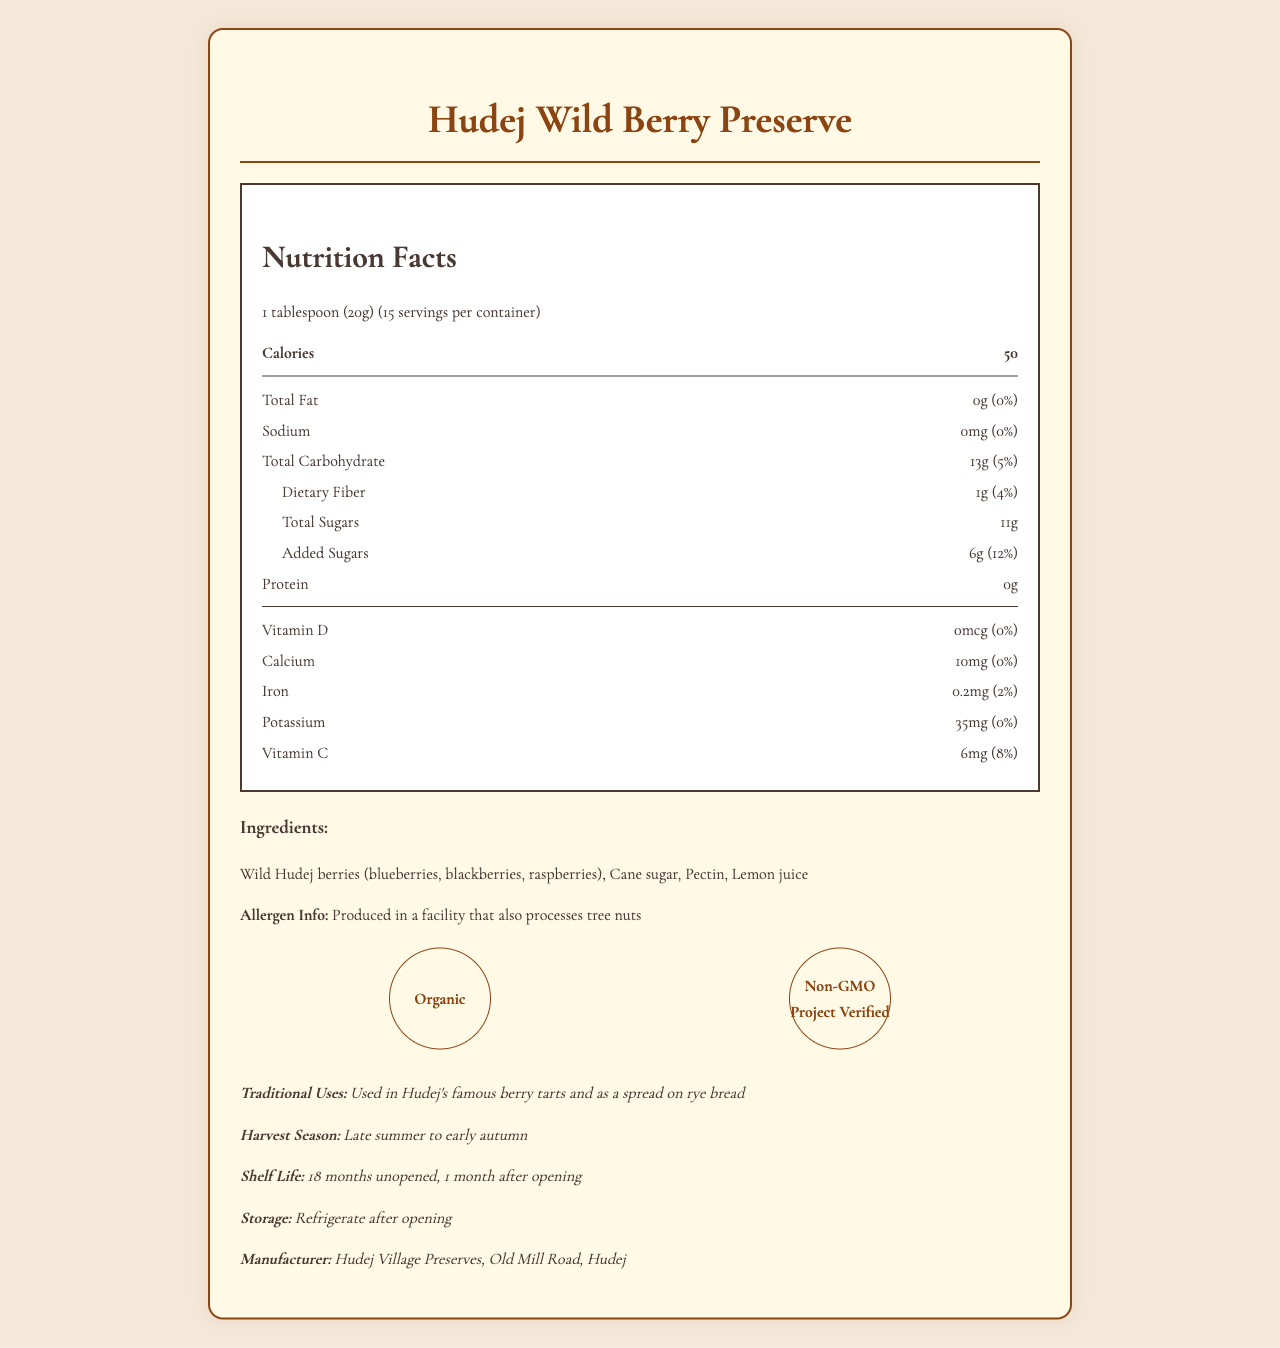what is the serving size? The document states that the serving size is 1 tablespoon, which is equivalent to 20 grams.
Answer: 1 tablespoon (20g) how many calories are in one serving? The "Calories" section of the Nutrition Facts Label shows that there are 50 calories per serving.
Answer: 50 calories what is the total fat content in one serving? The document lists total fat as 0 grams in one serving.
Answer: 0g how much dietary fiber is in a serving, and what percentage of the daily value does it represent? The Nutrition Facts Label states that there is 1 gram of dietary fiber per serving, which is 4% of the daily value.
Answer: 1g, 4% what are the traditional uses of this preserve? The additional information section mentions the traditional uses of the preserve.
Answer: Used in Hudej's famous berry tarts and as a spread on rye bread which of the following is not an ingredient in the preserve? A. Cane sugar B. Pectin C. Honey D. Lemon juice The ingredients listed are wild Hudej berries, cane sugar, pectin, and lemon juice. Honey is not an ingredient.
Answer: C. Honey how long is the shelf life of the unopened preserve? A. 12 months B. 18 months C. 24 months D. 6 months The additional information section specifies that the shelf life is 18 months unopened.
Answer: B. 18 months is this product suitable for someone with a tree nut allergy? The allergen information states that it is produced in a facility that also processes tree nuts, which could cross-contaminate the product.
Answer: No what certifications does the Hudej Wild Berry Preserve have? The certifications listed at the bottom of the document include "Organic" and "Non-GMO Project Verified."
Answer: Organic, Non-GMO Project Verified how many added sugars are in one serving? The Nutrition Facts Label shows that there are 6 grams of added sugars per serving.
Answer: 6g summarize the main nutritional information given in the document. The preservation offers essential nutritional data such as serving size, calorie content, macronutrients, and minor nutrients. It is distinguished by its usage and significant certifications.
Answer: The Hudej Wild Berry Preserve contains 1 tablespoon (20g) per serving, with 50 calories per serving. The preserve has 0g total fat, 0mg sodium, 13g total carbohydrates (5% DV), 1g dietary fiber (4% DV), 11g total sugars with 6g added sugars (12% DV), and 0g protein. It also contains small amounts of vitamin D, calcium, iron, potassium, and vitamin C. The product is organic and non-GMO, and is traditionally used in local berry tarts and as a spread on rye bread. what are the storage instructions for the preserve? The document advises refrigerating the preserve after opening.
Answer: Refrigerate after opening what is the main manufacturer information provided? The manufacturer information given is "Hudej Village Preserves, Old Mill Road, Hudej."
Answer: Hudej Village Preserves, Old Mill Road, Hudej what is the total carbohydrate content per serving, including dietary fiber and sugars? The document lists 13 grams of total carbohydrates per serving.
Answer: 13g when is the harvest season for the wild Hudej berries? The additional information section mentions that the harvest season is from late summer to early autumn.
Answer: Late summer to early autumn from which facility is the product produced? The document mentions it is produced in a facility that processes tree nuts but does not specify the name of the facility.
Answer: Not enough information 